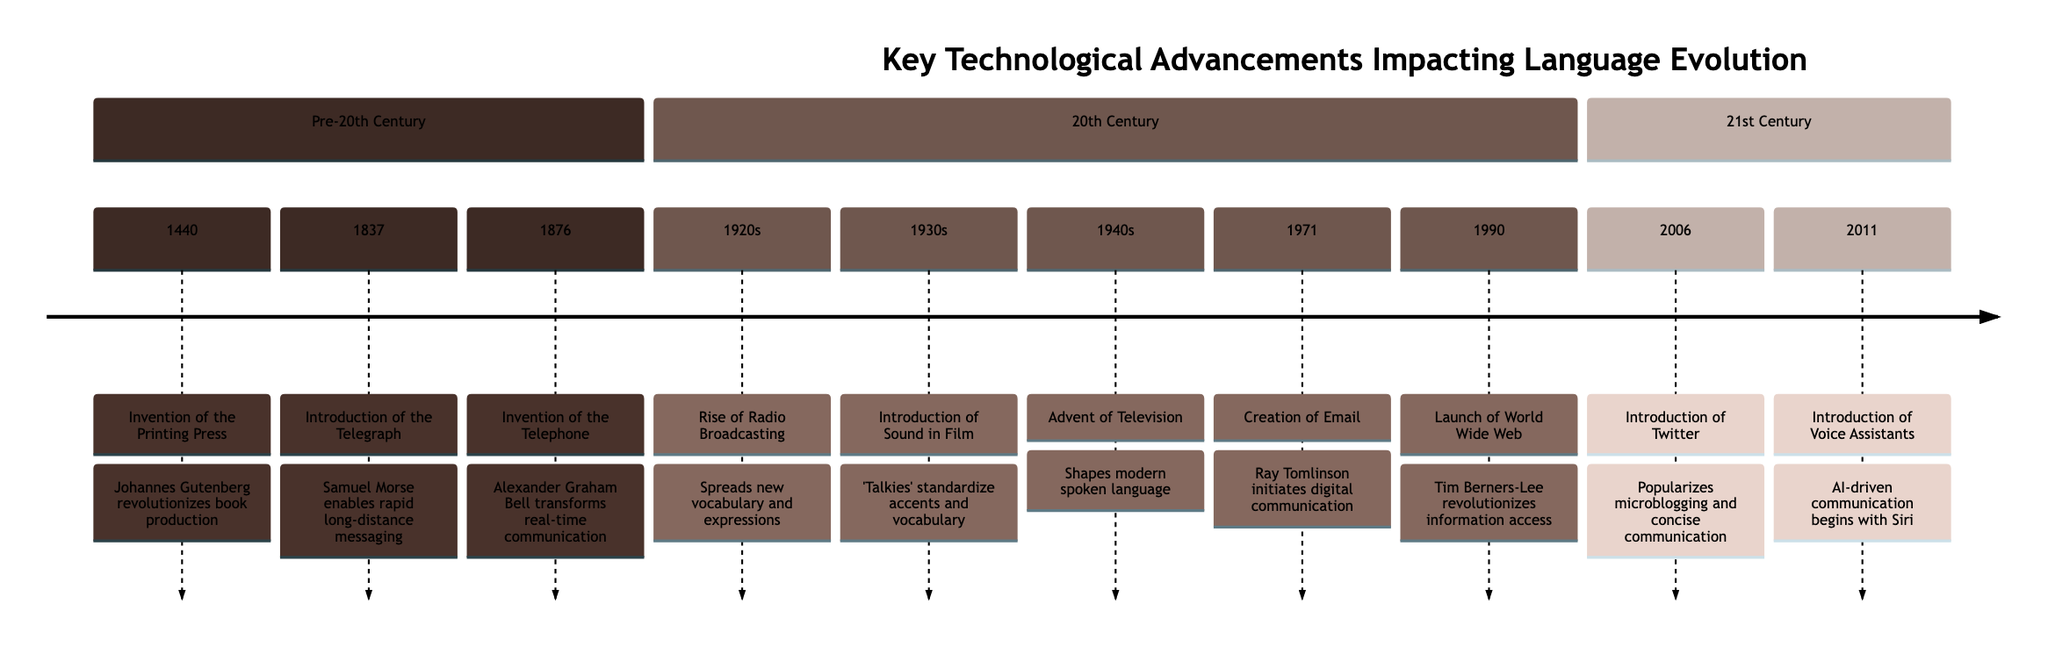What event occurred in 1876? According to the timeline, the event listed for the year 1876 is the "Invention of the Telephone."
Answer: Invention of the Telephone How many events are listed in the 20th Century section? There are seven events detailed in the 20th Century section of the timeline, which can be counted from the entries provided.
Answer: 7 What technological advancement began in 1940s? The timeline indicates that the "Advent of Television" is the technological advancement that began in the 1940s.
Answer: Advent of Television Which invention influenced the conciseness of written communication? The timeline specifies that the "Creation of Email" in 1971 influenced the brevity and formality of written language.
Answer: Creation of Email What is the earliest event related to communication technology on the timeline? The earliest event mentioned is the "Invention of the Printing Press," which occurred in 1440.
Answer: Invention of the Printing Press What impact did the introduction of sound in film have on language? The timeline notes that the introduction of sound in film in the 1930s began to standardize accents and vocabulary, which indicates its significant impact on language.
Answer: Standardized accents and vocabulary What year did the launch of the World Wide Web take place? According to the timeline, the launch of the World Wide Web occurred in the year 1990.
Answer: 1990 Which technological advancement initiated digital communication? The timeline points out that the "Creation of Email" in 1971 initiated digital communication.
Answer: Creation of Email What was a significant change for spoken language due to radio broadcasting? The timeline describes that the "Rise of Radio Broadcasting" in the 1920s influenced spoken language through the spread of new vocabulary and expressions.
Answer: Spread of new vocabulary and expressions 